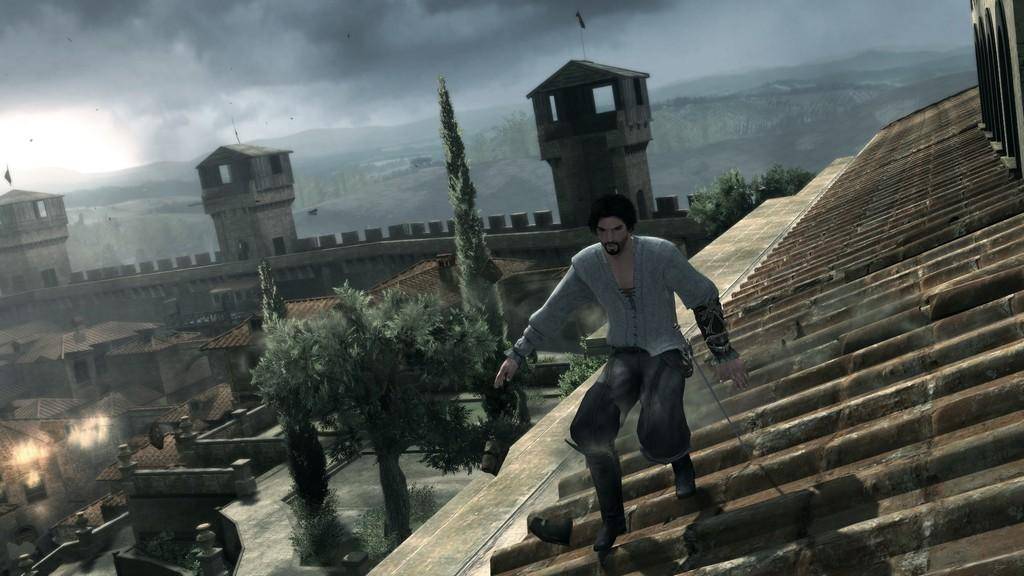What type of image is being described? The image is animated. What is the person in the image doing? The person is standing on a roof. What type of natural elements can be seen in the image? There are trees in the image. What type of man-made structures are present in the image? There are buildings in the image. What type of pie is being served by the doctor in the image? There is no doctor or pie present in the image. What time is indicated by the clock in the image? There is no clock present in the image. 